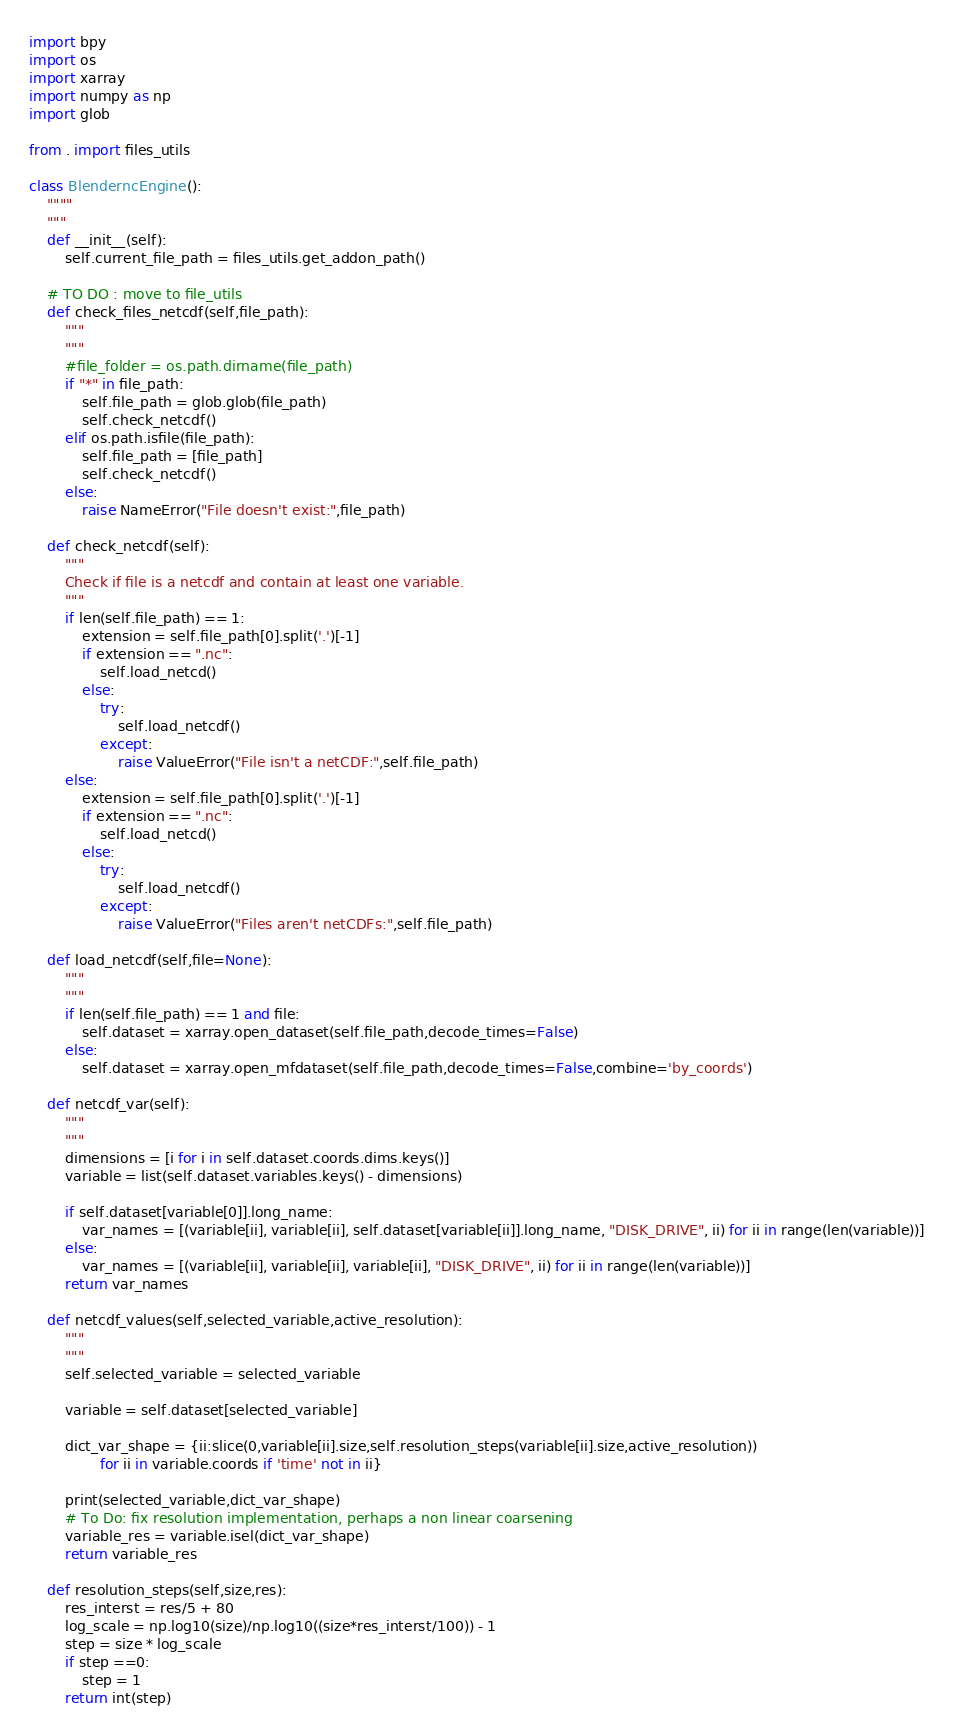<code> <loc_0><loc_0><loc_500><loc_500><_Python_>import bpy
import os
import xarray
import numpy as np
import glob

from . import files_utils

class BlenderncEngine():
    """"
    """
    def __init__(self):
        self.current_file_path = files_utils.get_addon_path()

    # TO DO : move to file_utils
    def check_files_netcdf(self,file_path):
        """
        """
        #file_folder = os.path.dirname(file_path)
        if "*" in file_path:
            self.file_path = glob.glob(file_path)
            self.check_netcdf()
        elif os.path.isfile(file_path):
            self.file_path = [file_path]
            self.check_netcdf()
        else:
            raise NameError("File doesn't exist:",file_path)
            
    def check_netcdf(self):
        """
        Check if file is a netcdf and contain at least one variable.
        """
        if len(self.file_path) == 1:
            extension = self.file_path[0].split('.')[-1]
            if extension == ".nc":
                self.load_netcd()
            else:
                try:
                    self.load_netcdf()
                except:
                    raise ValueError("File isn't a netCDF:",self.file_path)
        else:
            extension = self.file_path[0].split('.')[-1]
            if extension == ".nc":
                self.load_netcd()
            else:
                try:
                    self.load_netcdf()
                except:
                    raise ValueError("Files aren't netCDFs:",self.file_path)
            
    def load_netcdf(self,file=None):
        """
        """
        if len(self.file_path) == 1 and file:
            self.dataset = xarray.open_dataset(self.file_path,decode_times=False) 
        else:
            self.dataset = xarray.open_mfdataset(self.file_path,decode_times=False,combine='by_coords')

    def netcdf_var(self):
        """
        """
        dimensions = [i for i in self.dataset.coords.dims.keys()]
        variable = list(self.dataset.variables.keys() - dimensions)

        if self.dataset[variable[0]].long_name:
            var_names = [(variable[ii], variable[ii], self.dataset[variable[ii]].long_name, "DISK_DRIVE", ii) for ii in range(len(variable))]
        else:
            var_names = [(variable[ii], variable[ii], variable[ii], "DISK_DRIVE", ii) for ii in range(len(variable))]
        return var_names

    def netcdf_values(self,selected_variable,active_resolution):
        """
        """
        self.selected_variable = selected_variable

        variable = self.dataset[selected_variable]

        dict_var_shape = {ii:slice(0,variable[ii].size,self.resolution_steps(variable[ii].size,active_resolution))
                for ii in variable.coords if 'time' not in ii}
        
        print(selected_variable,dict_var_shape)
        # To Do: fix resolution implementation, perhaps a non linear coarsening
        variable_res = variable.isel(dict_var_shape)
        return variable_res
    
    def resolution_steps(self,size,res):
        res_interst = res/5 + 80
        log_scale = np.log10(size)/np.log10((size*res_interst/100)) - 1
        step = size * log_scale
        if step ==0:
            step = 1
        return int(step)</code> 